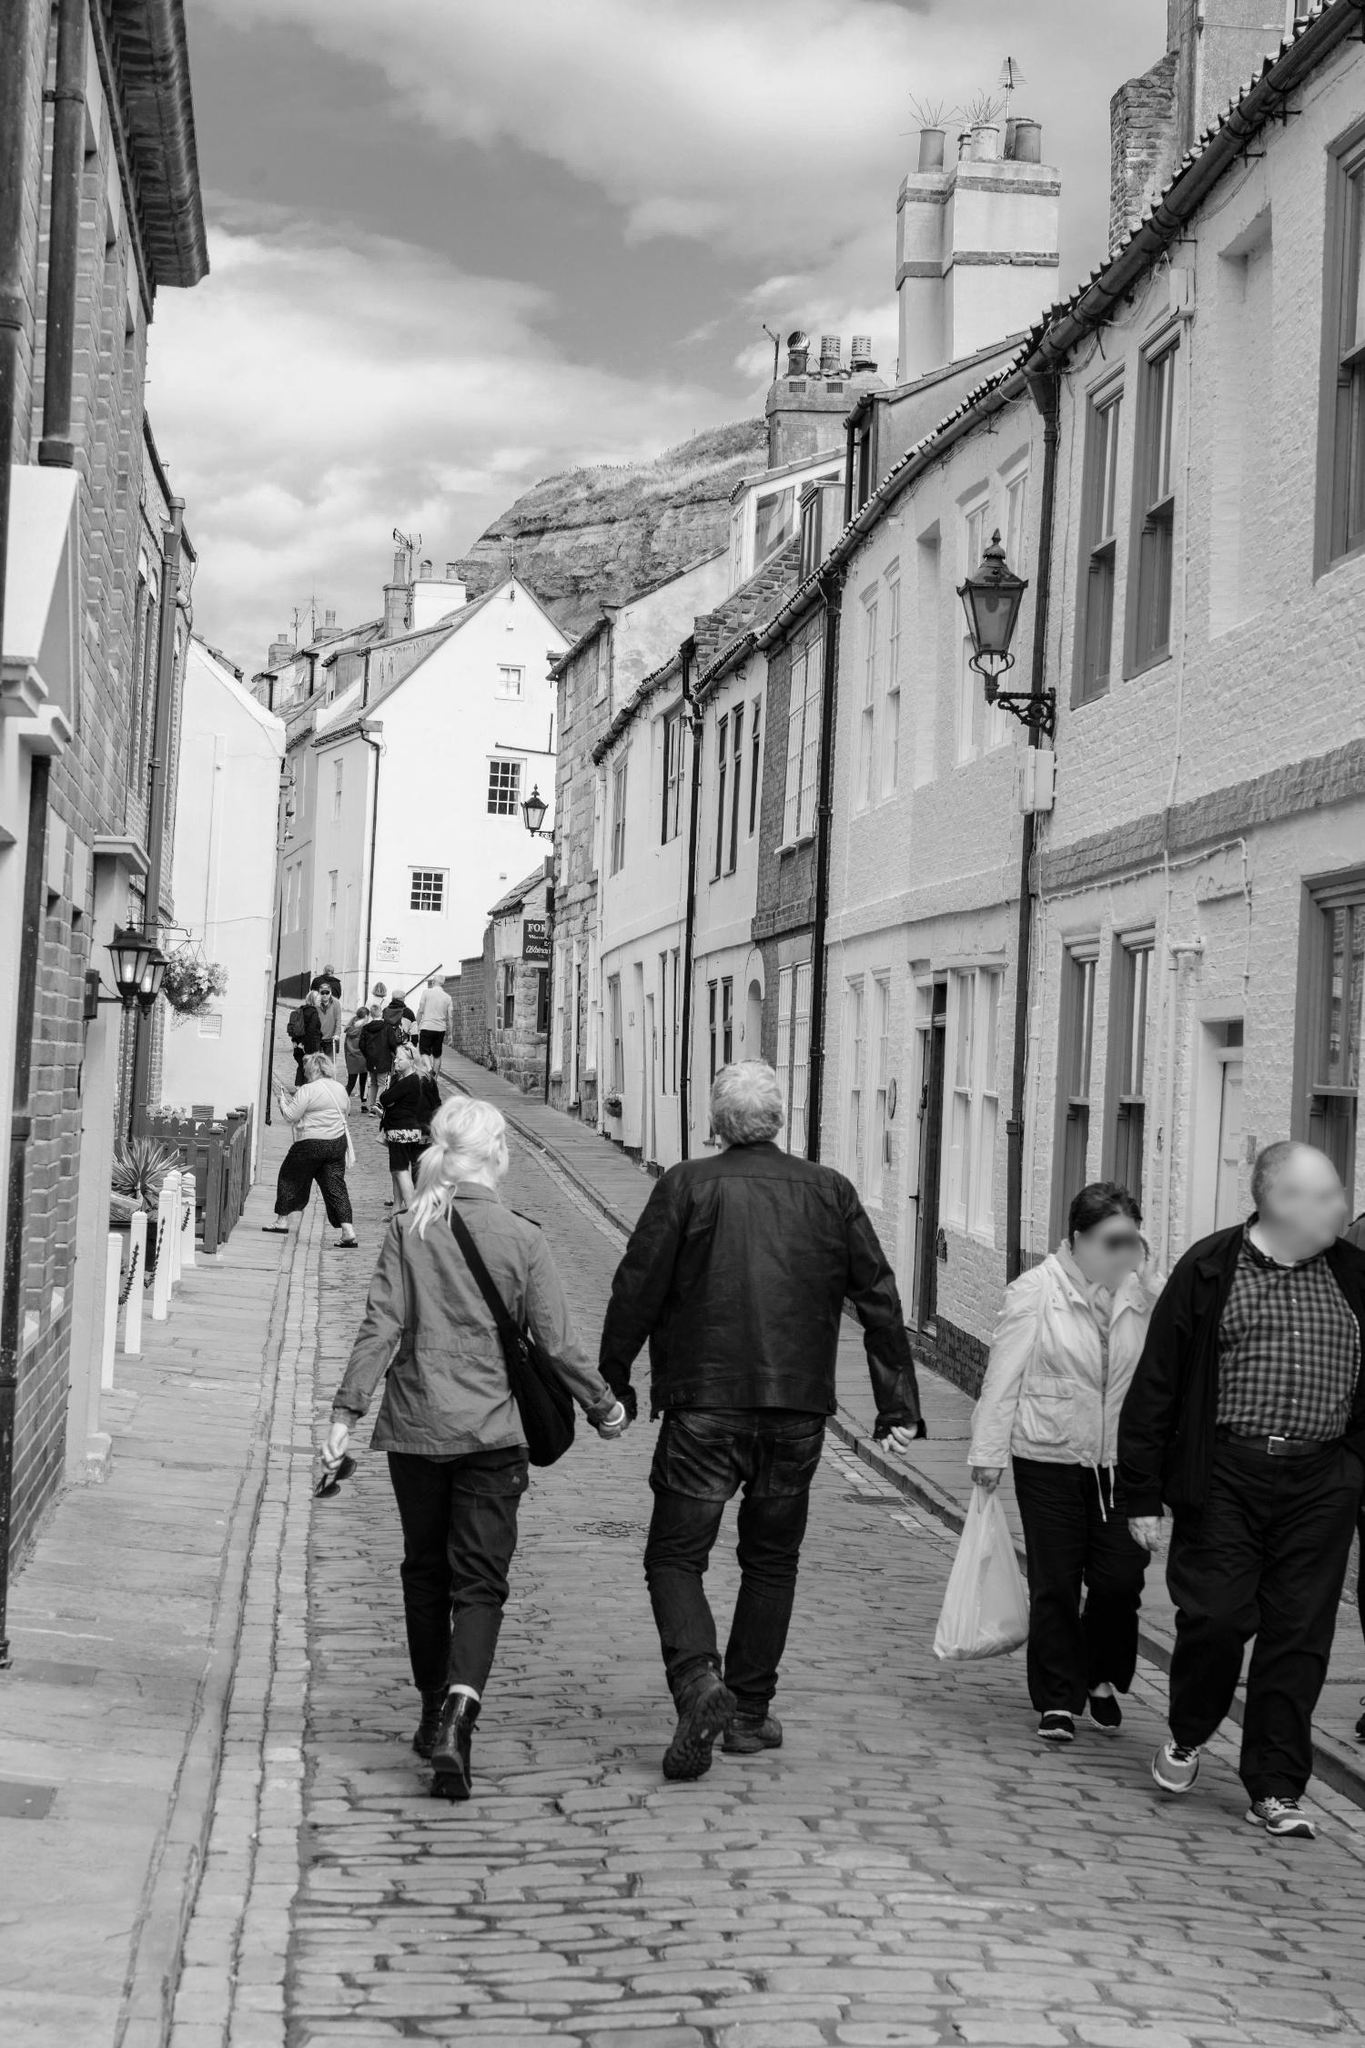Can you describe a typical morning in this town? A typical morning in this town begins with the soft light of dawn illuminating the white walls and black roofs of the buildings. The sound of cobblestones clicking underfoot mixes with the chirping of birds and the distant murmur of wakes. Shopkeepers open their wooden shutters, letting in the fresh morning air, and sweep the entrances of their shops. The aroma of freshly baked bread wafts through the air from the local bakery. Residents step out to buy their morning groceries, greet each other warmly, and share a few words. The street slowly comes alive with the buzz of everyday activities, yet retains its tranquil charm, under the watchful eye of the ancient castle in the distance. What if the castle in the background had a secret? Imagine if the castle in the background held a secret passageway hidden within its walls. This passage, known only to a select few, could lead to an underground network of tunnels used during times of conflict to move unseen through the countryside. Perhaps the town's founding family had forged an alliance with a nearby kingdom, and their clandestine meetings took place in an opulently decorated chamber deep beneath the castle. This secret could be the key to many ancient legends and mysteries surrounding the town, prompting treasure hunters and historians alike to uncover clues hidden in the cobblestones and ancient manuscripts preserved in the local archives.  If this street was the scene of a romantic tale, how would it unfold? Underneath the romantic ambiance of the cobblestone street, a beautiful tale could unfold. Imagine a young artist who visits the town and is enchanted by its charm. One morning, while sketching the castle from the street, the artist's attention is captured by a local baker who passes by each day, carrying fresh bread to the castle. Over time, stolen glances evolve into shy smiles. One rainy afternoon, as the artist struggles to shield the sketchpad, the baker approaches and shares an umbrella. This small act of kindness opens the door to conversations, shared walks up the street, and a deepening connection. They discover that the artist’s ancestors once lived in the castle, and together, they unlock stories of the past and create art that celebrates their growing love, culminating in a heartfelt confession under a moonlit sky. 